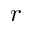Convert formula to latex. <formula><loc_0><loc_0><loc_500><loc_500>r</formula> 